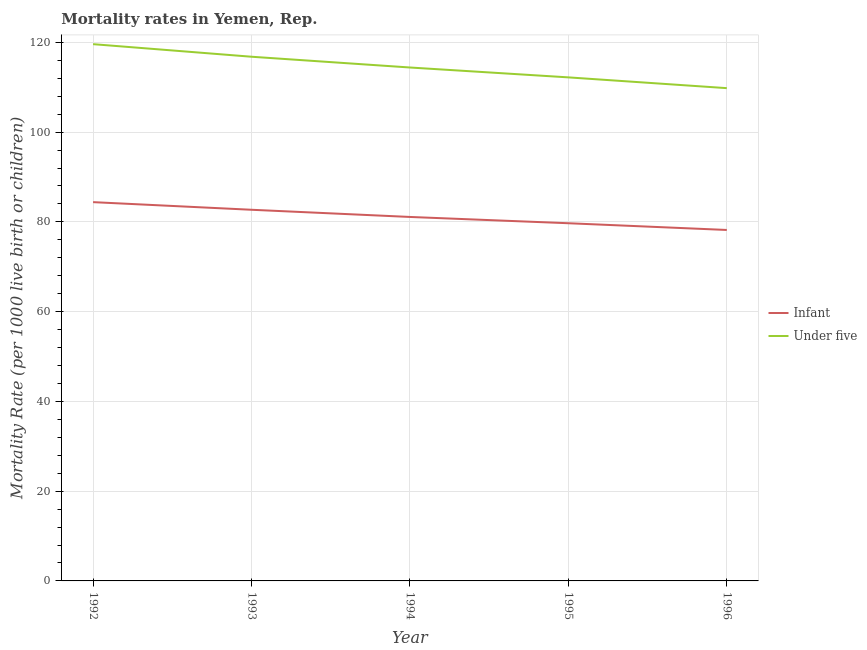How many different coloured lines are there?
Provide a succinct answer. 2. What is the infant mortality rate in 1996?
Offer a very short reply. 78.2. Across all years, what is the maximum under-5 mortality rate?
Give a very brief answer. 119.6. Across all years, what is the minimum under-5 mortality rate?
Offer a terse response. 109.8. In which year was the infant mortality rate maximum?
Give a very brief answer. 1992. What is the total infant mortality rate in the graph?
Offer a very short reply. 406.1. What is the difference between the under-5 mortality rate in 1993 and that in 1994?
Provide a succinct answer. 2.4. What is the difference between the under-5 mortality rate in 1993 and the infant mortality rate in 1994?
Keep it short and to the point. 35.7. What is the average under-5 mortality rate per year?
Ensure brevity in your answer.  114.56. In the year 1992, what is the difference between the infant mortality rate and under-5 mortality rate?
Your answer should be very brief. -35.2. What is the ratio of the infant mortality rate in 1995 to that in 1996?
Ensure brevity in your answer.  1.02. Is the under-5 mortality rate in 1993 less than that in 1995?
Ensure brevity in your answer.  No. Is the difference between the infant mortality rate in 1994 and 1995 greater than the difference between the under-5 mortality rate in 1994 and 1995?
Keep it short and to the point. No. What is the difference between the highest and the second highest under-5 mortality rate?
Your answer should be compact. 2.8. What is the difference between the highest and the lowest under-5 mortality rate?
Provide a short and direct response. 9.8. Is the sum of the infant mortality rate in 1992 and 1996 greater than the maximum under-5 mortality rate across all years?
Offer a terse response. Yes. Is the under-5 mortality rate strictly greater than the infant mortality rate over the years?
Offer a very short reply. Yes. How many lines are there?
Your answer should be compact. 2. How many years are there in the graph?
Make the answer very short. 5. What is the difference between two consecutive major ticks on the Y-axis?
Offer a terse response. 20. Does the graph contain any zero values?
Offer a very short reply. No. Where does the legend appear in the graph?
Make the answer very short. Center right. How many legend labels are there?
Offer a terse response. 2. What is the title of the graph?
Your answer should be compact. Mortality rates in Yemen, Rep. What is the label or title of the Y-axis?
Keep it short and to the point. Mortality Rate (per 1000 live birth or children). What is the Mortality Rate (per 1000 live birth or children) of Infant in 1992?
Offer a terse response. 84.4. What is the Mortality Rate (per 1000 live birth or children) in Under five in 1992?
Offer a very short reply. 119.6. What is the Mortality Rate (per 1000 live birth or children) in Infant in 1993?
Offer a terse response. 82.7. What is the Mortality Rate (per 1000 live birth or children) of Under five in 1993?
Your response must be concise. 116.8. What is the Mortality Rate (per 1000 live birth or children) in Infant in 1994?
Give a very brief answer. 81.1. What is the Mortality Rate (per 1000 live birth or children) of Under five in 1994?
Make the answer very short. 114.4. What is the Mortality Rate (per 1000 live birth or children) of Infant in 1995?
Ensure brevity in your answer.  79.7. What is the Mortality Rate (per 1000 live birth or children) in Under five in 1995?
Offer a very short reply. 112.2. What is the Mortality Rate (per 1000 live birth or children) in Infant in 1996?
Your response must be concise. 78.2. What is the Mortality Rate (per 1000 live birth or children) in Under five in 1996?
Provide a succinct answer. 109.8. Across all years, what is the maximum Mortality Rate (per 1000 live birth or children) of Infant?
Keep it short and to the point. 84.4. Across all years, what is the maximum Mortality Rate (per 1000 live birth or children) of Under five?
Your answer should be very brief. 119.6. Across all years, what is the minimum Mortality Rate (per 1000 live birth or children) of Infant?
Ensure brevity in your answer.  78.2. Across all years, what is the minimum Mortality Rate (per 1000 live birth or children) of Under five?
Keep it short and to the point. 109.8. What is the total Mortality Rate (per 1000 live birth or children) in Infant in the graph?
Offer a very short reply. 406.1. What is the total Mortality Rate (per 1000 live birth or children) of Under five in the graph?
Your answer should be very brief. 572.8. What is the difference between the Mortality Rate (per 1000 live birth or children) in Infant in 1992 and that in 1993?
Your answer should be compact. 1.7. What is the difference between the Mortality Rate (per 1000 live birth or children) in Under five in 1992 and that in 1995?
Offer a very short reply. 7.4. What is the difference between the Mortality Rate (per 1000 live birth or children) of Under five in 1992 and that in 1996?
Your response must be concise. 9.8. What is the difference between the Mortality Rate (per 1000 live birth or children) of Infant in 1993 and that in 1994?
Your answer should be very brief. 1.6. What is the difference between the Mortality Rate (per 1000 live birth or children) of Under five in 1993 and that in 1994?
Your response must be concise. 2.4. What is the difference between the Mortality Rate (per 1000 live birth or children) of Infant in 1993 and that in 1995?
Your answer should be compact. 3. What is the difference between the Mortality Rate (per 1000 live birth or children) of Under five in 1993 and that in 1995?
Offer a terse response. 4.6. What is the difference between the Mortality Rate (per 1000 live birth or children) in Under five in 1994 and that in 1995?
Your answer should be very brief. 2.2. What is the difference between the Mortality Rate (per 1000 live birth or children) in Infant in 1994 and that in 1996?
Provide a short and direct response. 2.9. What is the difference between the Mortality Rate (per 1000 live birth or children) of Under five in 1994 and that in 1996?
Provide a succinct answer. 4.6. What is the difference between the Mortality Rate (per 1000 live birth or children) of Infant in 1995 and that in 1996?
Offer a very short reply. 1.5. What is the difference between the Mortality Rate (per 1000 live birth or children) in Infant in 1992 and the Mortality Rate (per 1000 live birth or children) in Under five in 1993?
Make the answer very short. -32.4. What is the difference between the Mortality Rate (per 1000 live birth or children) of Infant in 1992 and the Mortality Rate (per 1000 live birth or children) of Under five in 1995?
Your answer should be very brief. -27.8. What is the difference between the Mortality Rate (per 1000 live birth or children) of Infant in 1992 and the Mortality Rate (per 1000 live birth or children) of Under five in 1996?
Provide a short and direct response. -25.4. What is the difference between the Mortality Rate (per 1000 live birth or children) of Infant in 1993 and the Mortality Rate (per 1000 live birth or children) of Under five in 1994?
Your answer should be compact. -31.7. What is the difference between the Mortality Rate (per 1000 live birth or children) of Infant in 1993 and the Mortality Rate (per 1000 live birth or children) of Under five in 1995?
Offer a very short reply. -29.5. What is the difference between the Mortality Rate (per 1000 live birth or children) of Infant in 1993 and the Mortality Rate (per 1000 live birth or children) of Under five in 1996?
Offer a terse response. -27.1. What is the difference between the Mortality Rate (per 1000 live birth or children) in Infant in 1994 and the Mortality Rate (per 1000 live birth or children) in Under five in 1995?
Your response must be concise. -31.1. What is the difference between the Mortality Rate (per 1000 live birth or children) of Infant in 1994 and the Mortality Rate (per 1000 live birth or children) of Under five in 1996?
Provide a succinct answer. -28.7. What is the difference between the Mortality Rate (per 1000 live birth or children) of Infant in 1995 and the Mortality Rate (per 1000 live birth or children) of Under five in 1996?
Give a very brief answer. -30.1. What is the average Mortality Rate (per 1000 live birth or children) in Infant per year?
Provide a succinct answer. 81.22. What is the average Mortality Rate (per 1000 live birth or children) in Under five per year?
Make the answer very short. 114.56. In the year 1992, what is the difference between the Mortality Rate (per 1000 live birth or children) in Infant and Mortality Rate (per 1000 live birth or children) in Under five?
Provide a succinct answer. -35.2. In the year 1993, what is the difference between the Mortality Rate (per 1000 live birth or children) of Infant and Mortality Rate (per 1000 live birth or children) of Under five?
Offer a very short reply. -34.1. In the year 1994, what is the difference between the Mortality Rate (per 1000 live birth or children) of Infant and Mortality Rate (per 1000 live birth or children) of Under five?
Provide a succinct answer. -33.3. In the year 1995, what is the difference between the Mortality Rate (per 1000 live birth or children) of Infant and Mortality Rate (per 1000 live birth or children) of Under five?
Keep it short and to the point. -32.5. In the year 1996, what is the difference between the Mortality Rate (per 1000 live birth or children) of Infant and Mortality Rate (per 1000 live birth or children) of Under five?
Your answer should be very brief. -31.6. What is the ratio of the Mortality Rate (per 1000 live birth or children) of Infant in 1992 to that in 1993?
Your answer should be compact. 1.02. What is the ratio of the Mortality Rate (per 1000 live birth or children) in Under five in 1992 to that in 1993?
Make the answer very short. 1.02. What is the ratio of the Mortality Rate (per 1000 live birth or children) in Infant in 1992 to that in 1994?
Offer a terse response. 1.04. What is the ratio of the Mortality Rate (per 1000 live birth or children) of Under five in 1992 to that in 1994?
Your answer should be very brief. 1.05. What is the ratio of the Mortality Rate (per 1000 live birth or children) of Infant in 1992 to that in 1995?
Ensure brevity in your answer.  1.06. What is the ratio of the Mortality Rate (per 1000 live birth or children) of Under five in 1992 to that in 1995?
Offer a very short reply. 1.07. What is the ratio of the Mortality Rate (per 1000 live birth or children) of Infant in 1992 to that in 1996?
Your response must be concise. 1.08. What is the ratio of the Mortality Rate (per 1000 live birth or children) of Under five in 1992 to that in 1996?
Give a very brief answer. 1.09. What is the ratio of the Mortality Rate (per 1000 live birth or children) of Infant in 1993 to that in 1994?
Your answer should be very brief. 1.02. What is the ratio of the Mortality Rate (per 1000 live birth or children) in Under five in 1993 to that in 1994?
Your answer should be very brief. 1.02. What is the ratio of the Mortality Rate (per 1000 live birth or children) of Infant in 1993 to that in 1995?
Keep it short and to the point. 1.04. What is the ratio of the Mortality Rate (per 1000 live birth or children) in Under five in 1993 to that in 1995?
Provide a succinct answer. 1.04. What is the ratio of the Mortality Rate (per 1000 live birth or children) in Infant in 1993 to that in 1996?
Your answer should be compact. 1.06. What is the ratio of the Mortality Rate (per 1000 live birth or children) in Under five in 1993 to that in 1996?
Offer a very short reply. 1.06. What is the ratio of the Mortality Rate (per 1000 live birth or children) in Infant in 1994 to that in 1995?
Give a very brief answer. 1.02. What is the ratio of the Mortality Rate (per 1000 live birth or children) in Under five in 1994 to that in 1995?
Provide a succinct answer. 1.02. What is the ratio of the Mortality Rate (per 1000 live birth or children) in Infant in 1994 to that in 1996?
Ensure brevity in your answer.  1.04. What is the ratio of the Mortality Rate (per 1000 live birth or children) of Under five in 1994 to that in 1996?
Keep it short and to the point. 1.04. What is the ratio of the Mortality Rate (per 1000 live birth or children) of Infant in 1995 to that in 1996?
Your answer should be compact. 1.02. What is the ratio of the Mortality Rate (per 1000 live birth or children) of Under five in 1995 to that in 1996?
Provide a short and direct response. 1.02. What is the difference between the highest and the lowest Mortality Rate (per 1000 live birth or children) of Infant?
Your response must be concise. 6.2. What is the difference between the highest and the lowest Mortality Rate (per 1000 live birth or children) in Under five?
Keep it short and to the point. 9.8. 